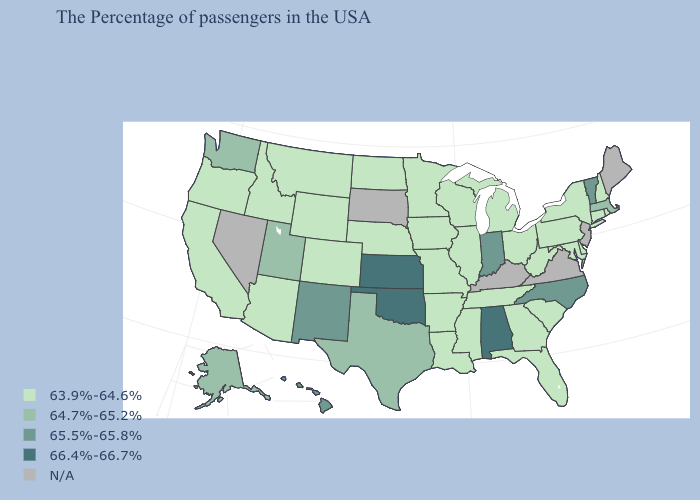Name the states that have a value in the range 64.7%-65.2%?
Short answer required. Massachusetts, Texas, Utah, Washington, Alaska. Which states have the lowest value in the South?
Short answer required. Delaware, Maryland, South Carolina, West Virginia, Florida, Georgia, Tennessee, Mississippi, Louisiana, Arkansas. Which states have the lowest value in the Northeast?
Quick response, please. Rhode Island, New Hampshire, Connecticut, New York, Pennsylvania. What is the value of New York?
Quick response, please. 63.9%-64.6%. What is the value of Nebraska?
Answer briefly. 63.9%-64.6%. Name the states that have a value in the range 66.4%-66.7%?
Keep it brief. Alabama, Kansas, Oklahoma. What is the value of Indiana?
Keep it brief. 65.5%-65.8%. Does Missouri have the lowest value in the MidWest?
Be succinct. Yes. What is the value of Delaware?
Be succinct. 63.9%-64.6%. What is the value of Michigan?
Short answer required. 63.9%-64.6%. Which states have the highest value in the USA?
Answer briefly. Alabama, Kansas, Oklahoma. Which states hav the highest value in the West?
Be succinct. New Mexico, Hawaii. What is the highest value in states that border Maryland?
Short answer required. 63.9%-64.6%. 